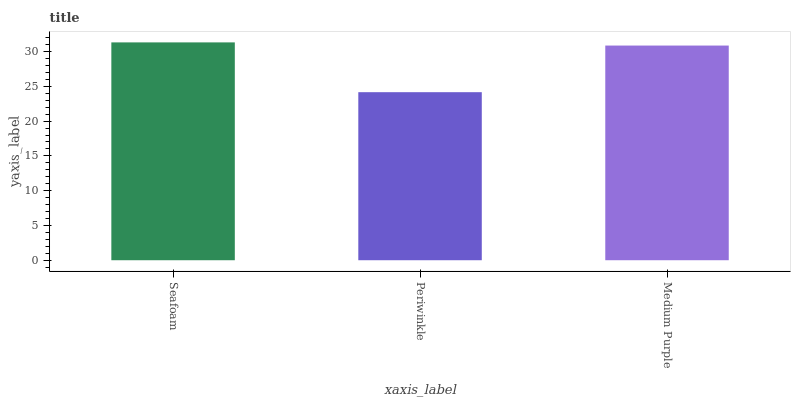Is Periwinkle the minimum?
Answer yes or no. Yes. Is Seafoam the maximum?
Answer yes or no. Yes. Is Medium Purple the minimum?
Answer yes or no. No. Is Medium Purple the maximum?
Answer yes or no. No. Is Medium Purple greater than Periwinkle?
Answer yes or no. Yes. Is Periwinkle less than Medium Purple?
Answer yes or no. Yes. Is Periwinkle greater than Medium Purple?
Answer yes or no. No. Is Medium Purple less than Periwinkle?
Answer yes or no. No. Is Medium Purple the high median?
Answer yes or no. Yes. Is Medium Purple the low median?
Answer yes or no. Yes. Is Periwinkle the high median?
Answer yes or no. No. Is Seafoam the low median?
Answer yes or no. No. 